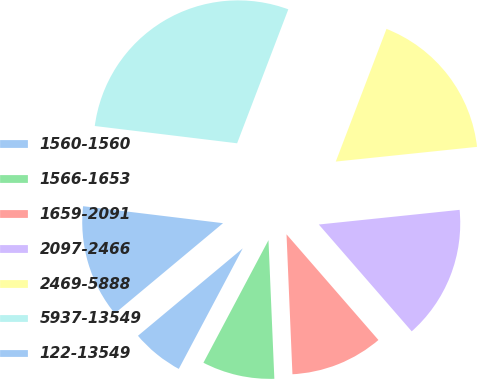Convert chart to OTSL. <chart><loc_0><loc_0><loc_500><loc_500><pie_chart><fcel>1560-1560<fcel>1566-1653<fcel>1659-2091<fcel>2097-2466<fcel>2469-5888<fcel>5937-13549<fcel>122-13549<nl><fcel>6.17%<fcel>8.44%<fcel>10.72%<fcel>15.26%<fcel>17.54%<fcel>28.89%<fcel>12.99%<nl></chart> 